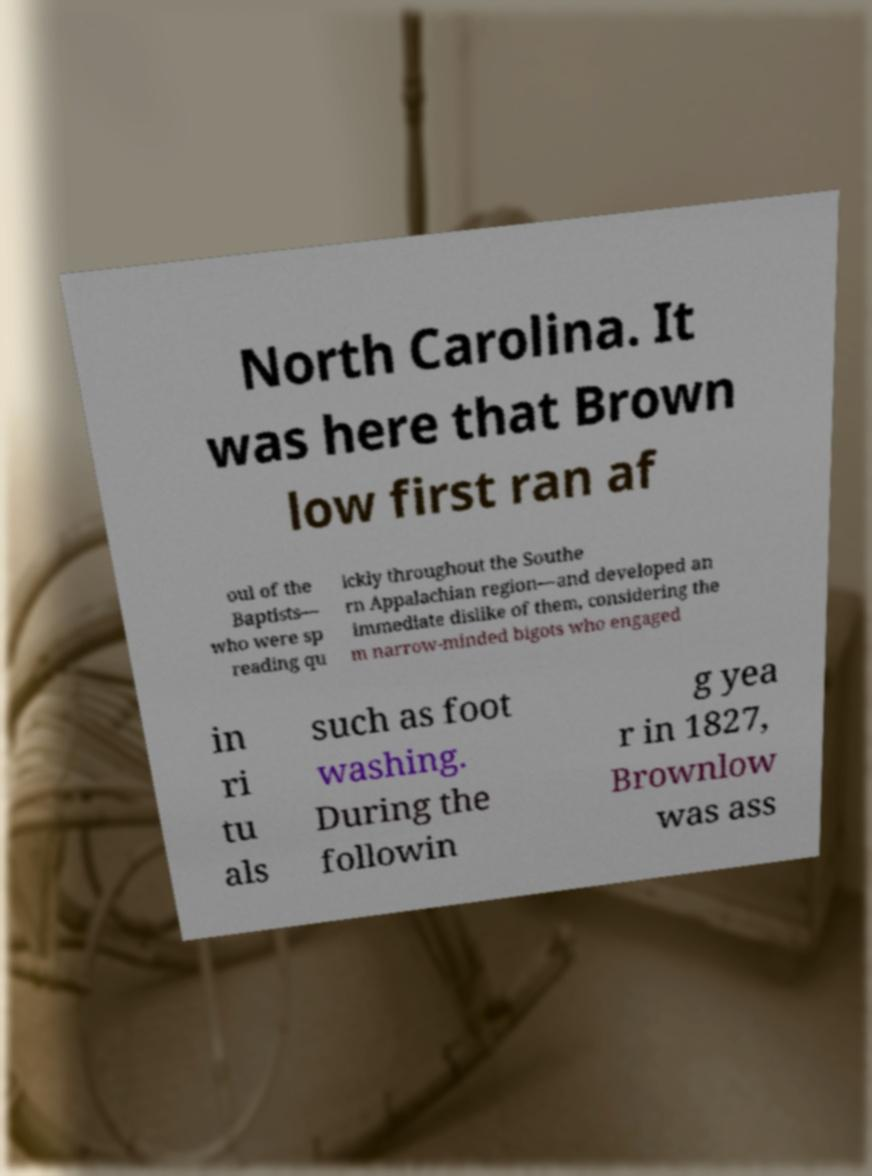I need the written content from this picture converted into text. Can you do that? North Carolina. It was here that Brown low first ran af oul of the Baptists— who were sp reading qu ickly throughout the Southe rn Appalachian region—and developed an immediate dislike of them, considering the m narrow-minded bigots who engaged in ri tu als such as foot washing. During the followin g yea r in 1827, Brownlow was ass 